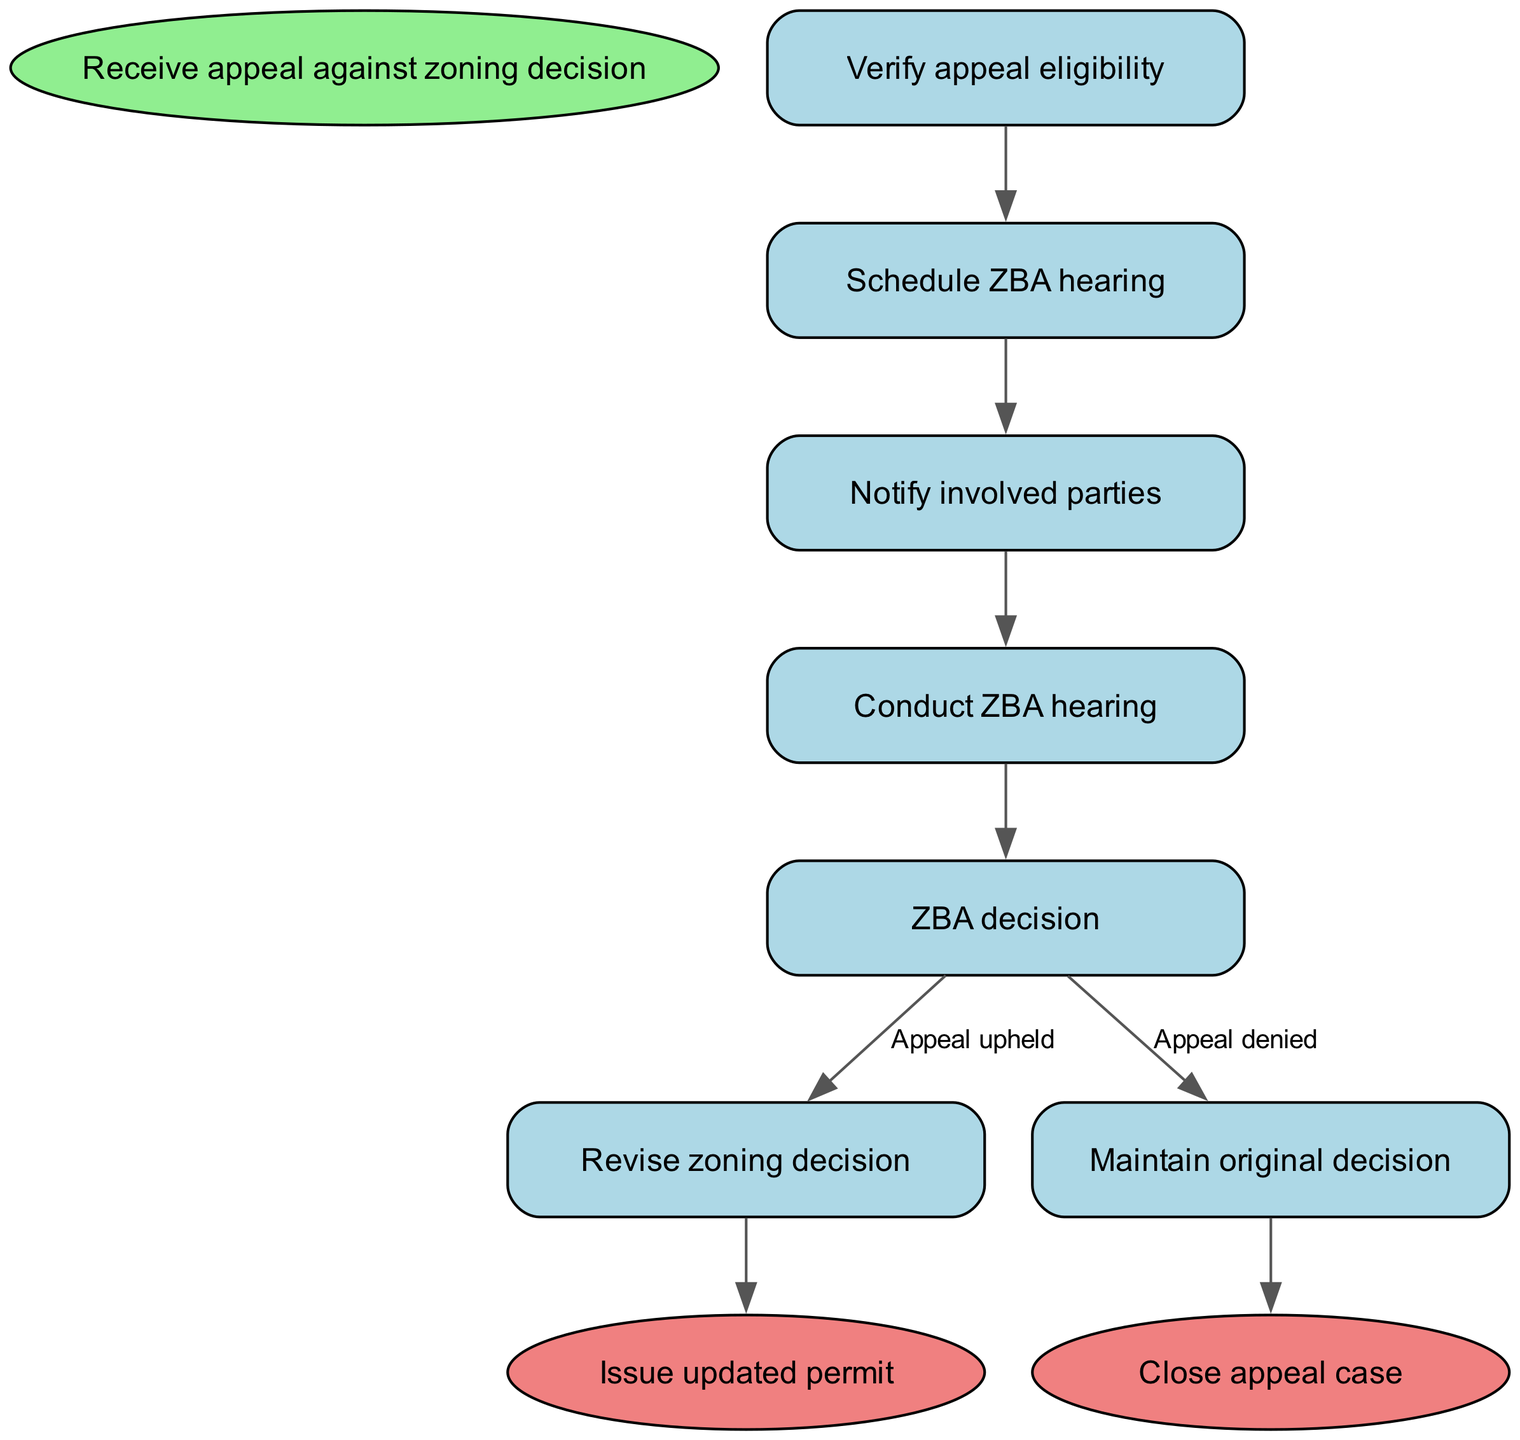What is the starting point of the appeal process? The diagram indicates that the process starts with the node labeled "Receive appeal against zoning decision." This is the first step shown in the flow chart.
Answer: Receive appeal against zoning decision How many steps are there in the procedure? By counting the nodes in the flowchart for the steps from start to finish, there are five steps in the main procedure before reaching the end.
Answer: Five What action follows after verifying appeal eligibility? Based on the flow, the next action that follows "Verify appeal eligibility" is "Schedule ZBA hearing," as indicated by the directed edge connecting these two nodes.
Answer: Schedule ZBA hearing What decision follows the ZBA hearing step? After conducting the "Conduct ZBA hearing," the next step is "ZBA decision." This transition is clearly pointed out in the flow chart.
Answer: ZBA decision What happens if the appeal is upheld? According to the diagram, if the "ZBA decision" results in the appeal being upheld, the action following this condition is "Revise zoning decision." This is an explicit condition-action connection in the flow.
Answer: Revise zoning decision If the appeal is denied, what is the next step? The diagram specifies that if the "ZBA decision" denies the appeal, the subsequent action is to "Maintain original decision." This is detailed under the respective condition associated with the decision node.
Answer: Maintain original decision What is the final outcome if the zoning decision is revised? Upon revising the zoning decision, the final action indicated in the flow chart is to "Issue updated permit." Therefore, this is the ultimate output from this decision path.
Answer: Issue updated permit What happens to the appeal case after maintaining the original decision? The diagram explicitly states that if the original decision is maintained, the next step is to "Close appeal case." This action follows the node for maintaining the decision.
Answer: Close appeal case What type of decision-making is shown in the ZBA decision step? The diagram highlights a bifurcation in the ZBA decision step, where two possible outcomes lead to different paths: either the appeal is upheld or denied, indicating a decision-making process with conditional outcomes.
Answer: Conditional decision-making 